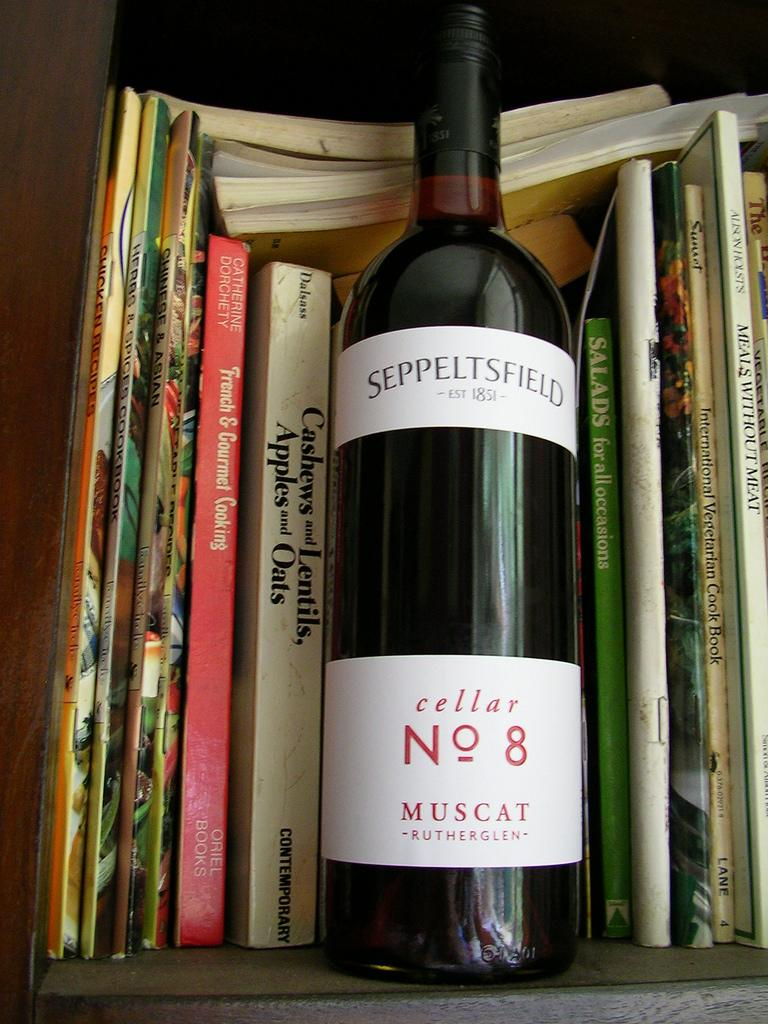Provide a one-sentence caption for the provided image. A bottle of cellar No 8 sits on a shelf with some books. 